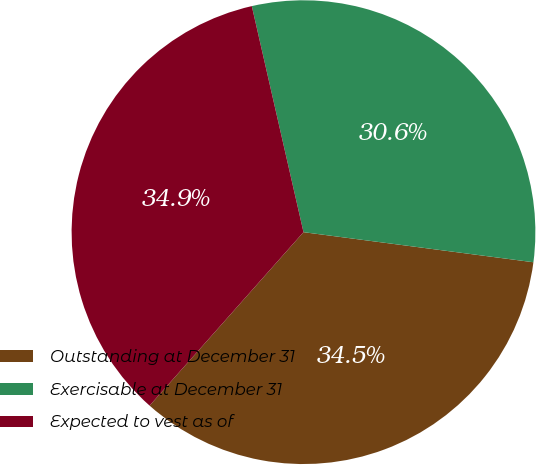<chart> <loc_0><loc_0><loc_500><loc_500><pie_chart><fcel>Outstanding at December 31<fcel>Exercisable at December 31<fcel>Expected to vest as of<nl><fcel>34.48%<fcel>30.65%<fcel>34.87%<nl></chart> 